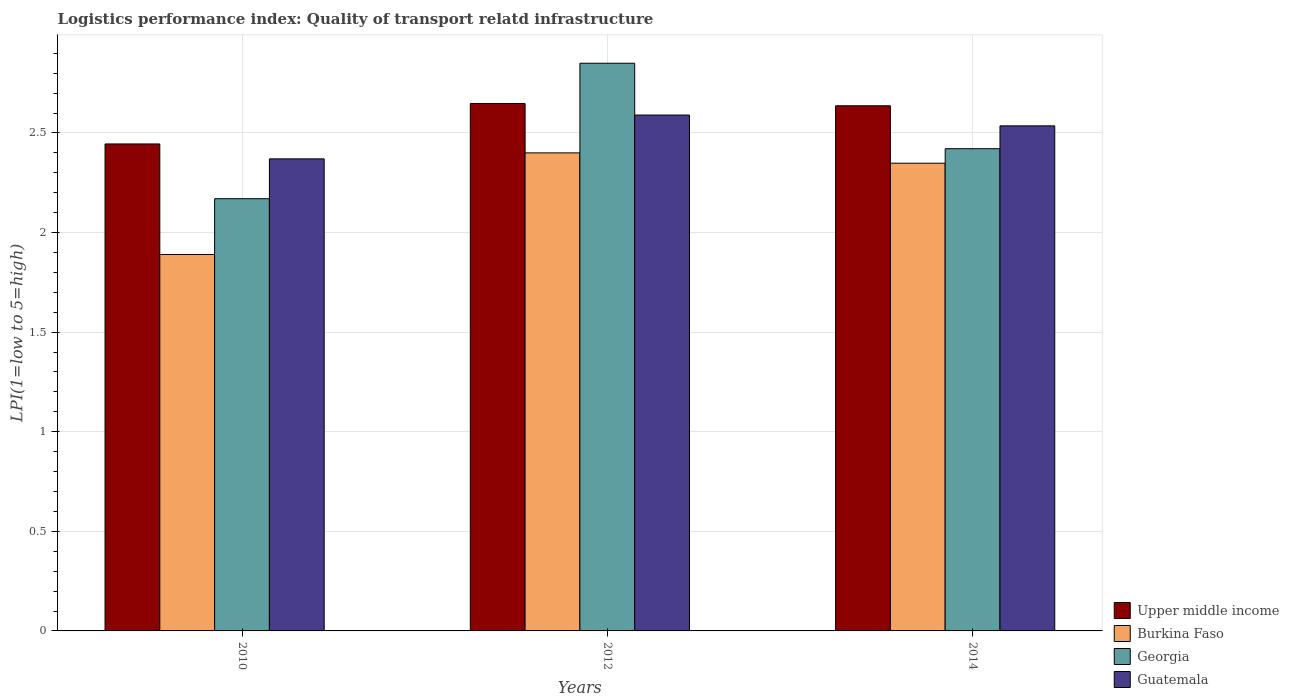Are the number of bars on each tick of the X-axis equal?
Provide a short and direct response. Yes. What is the label of the 1st group of bars from the left?
Make the answer very short. 2010. What is the logistics performance index in Guatemala in 2010?
Make the answer very short. 2.37. Across all years, what is the minimum logistics performance index in Upper middle income?
Your answer should be very brief. 2.44. In which year was the logistics performance index in Upper middle income minimum?
Your response must be concise. 2010. What is the total logistics performance index in Upper middle income in the graph?
Offer a very short reply. 7.73. What is the difference between the logistics performance index in Burkina Faso in 2012 and that in 2014?
Your response must be concise. 0.05. What is the difference between the logistics performance index in Georgia in 2010 and the logistics performance index in Upper middle income in 2012?
Offer a terse response. -0.48. What is the average logistics performance index in Upper middle income per year?
Your answer should be very brief. 2.58. In the year 2010, what is the difference between the logistics performance index in Upper middle income and logistics performance index in Georgia?
Offer a very short reply. 0.27. In how many years, is the logistics performance index in Upper middle income greater than 2.7?
Give a very brief answer. 0. What is the ratio of the logistics performance index in Georgia in 2010 to that in 2014?
Your answer should be compact. 0.9. Is the difference between the logistics performance index in Upper middle income in 2010 and 2014 greater than the difference between the logistics performance index in Georgia in 2010 and 2014?
Provide a succinct answer. Yes. What is the difference between the highest and the second highest logistics performance index in Georgia?
Provide a short and direct response. 0.43. What is the difference between the highest and the lowest logistics performance index in Burkina Faso?
Your response must be concise. 0.51. Is the sum of the logistics performance index in Guatemala in 2012 and 2014 greater than the maximum logistics performance index in Upper middle income across all years?
Your answer should be compact. Yes. Is it the case that in every year, the sum of the logistics performance index in Upper middle income and logistics performance index in Burkina Faso is greater than the sum of logistics performance index in Guatemala and logistics performance index in Georgia?
Your response must be concise. No. What does the 1st bar from the left in 2010 represents?
Ensure brevity in your answer.  Upper middle income. What does the 1st bar from the right in 2014 represents?
Keep it short and to the point. Guatemala. Are all the bars in the graph horizontal?
Keep it short and to the point. No. What is the difference between two consecutive major ticks on the Y-axis?
Your answer should be very brief. 0.5. Does the graph contain any zero values?
Give a very brief answer. No. How many legend labels are there?
Give a very brief answer. 4. What is the title of the graph?
Make the answer very short. Logistics performance index: Quality of transport relatd infrastructure. What is the label or title of the Y-axis?
Keep it short and to the point. LPI(1=low to 5=high). What is the LPI(1=low to 5=high) of Upper middle income in 2010?
Your answer should be compact. 2.44. What is the LPI(1=low to 5=high) in Burkina Faso in 2010?
Offer a very short reply. 1.89. What is the LPI(1=low to 5=high) in Georgia in 2010?
Your answer should be very brief. 2.17. What is the LPI(1=low to 5=high) of Guatemala in 2010?
Your response must be concise. 2.37. What is the LPI(1=low to 5=high) in Upper middle income in 2012?
Provide a succinct answer. 2.65. What is the LPI(1=low to 5=high) in Georgia in 2012?
Your answer should be very brief. 2.85. What is the LPI(1=low to 5=high) of Guatemala in 2012?
Offer a terse response. 2.59. What is the LPI(1=low to 5=high) of Upper middle income in 2014?
Your answer should be compact. 2.64. What is the LPI(1=low to 5=high) of Burkina Faso in 2014?
Make the answer very short. 2.35. What is the LPI(1=low to 5=high) of Georgia in 2014?
Your answer should be very brief. 2.42. What is the LPI(1=low to 5=high) in Guatemala in 2014?
Your answer should be very brief. 2.54. Across all years, what is the maximum LPI(1=low to 5=high) in Upper middle income?
Provide a short and direct response. 2.65. Across all years, what is the maximum LPI(1=low to 5=high) in Burkina Faso?
Your answer should be very brief. 2.4. Across all years, what is the maximum LPI(1=low to 5=high) of Georgia?
Provide a short and direct response. 2.85. Across all years, what is the maximum LPI(1=low to 5=high) of Guatemala?
Offer a very short reply. 2.59. Across all years, what is the minimum LPI(1=low to 5=high) in Upper middle income?
Give a very brief answer. 2.44. Across all years, what is the minimum LPI(1=low to 5=high) in Burkina Faso?
Keep it short and to the point. 1.89. Across all years, what is the minimum LPI(1=low to 5=high) of Georgia?
Your response must be concise. 2.17. Across all years, what is the minimum LPI(1=low to 5=high) in Guatemala?
Make the answer very short. 2.37. What is the total LPI(1=low to 5=high) of Upper middle income in the graph?
Provide a short and direct response. 7.73. What is the total LPI(1=low to 5=high) in Burkina Faso in the graph?
Give a very brief answer. 6.64. What is the total LPI(1=low to 5=high) of Georgia in the graph?
Your answer should be compact. 7.44. What is the total LPI(1=low to 5=high) in Guatemala in the graph?
Give a very brief answer. 7.5. What is the difference between the LPI(1=low to 5=high) of Upper middle income in 2010 and that in 2012?
Give a very brief answer. -0.2. What is the difference between the LPI(1=low to 5=high) of Burkina Faso in 2010 and that in 2012?
Your response must be concise. -0.51. What is the difference between the LPI(1=low to 5=high) in Georgia in 2010 and that in 2012?
Provide a short and direct response. -0.68. What is the difference between the LPI(1=low to 5=high) in Guatemala in 2010 and that in 2012?
Offer a very short reply. -0.22. What is the difference between the LPI(1=low to 5=high) in Upper middle income in 2010 and that in 2014?
Give a very brief answer. -0.19. What is the difference between the LPI(1=low to 5=high) of Burkina Faso in 2010 and that in 2014?
Keep it short and to the point. -0.46. What is the difference between the LPI(1=low to 5=high) of Georgia in 2010 and that in 2014?
Provide a succinct answer. -0.25. What is the difference between the LPI(1=low to 5=high) of Guatemala in 2010 and that in 2014?
Make the answer very short. -0.17. What is the difference between the LPI(1=low to 5=high) of Upper middle income in 2012 and that in 2014?
Offer a very short reply. 0.01. What is the difference between the LPI(1=low to 5=high) of Burkina Faso in 2012 and that in 2014?
Provide a succinct answer. 0.05. What is the difference between the LPI(1=low to 5=high) in Georgia in 2012 and that in 2014?
Keep it short and to the point. 0.43. What is the difference between the LPI(1=low to 5=high) in Guatemala in 2012 and that in 2014?
Your answer should be compact. 0.05. What is the difference between the LPI(1=low to 5=high) of Upper middle income in 2010 and the LPI(1=low to 5=high) of Burkina Faso in 2012?
Your answer should be very brief. 0.04. What is the difference between the LPI(1=low to 5=high) of Upper middle income in 2010 and the LPI(1=low to 5=high) of Georgia in 2012?
Provide a short and direct response. -0.41. What is the difference between the LPI(1=low to 5=high) of Upper middle income in 2010 and the LPI(1=low to 5=high) of Guatemala in 2012?
Give a very brief answer. -0.15. What is the difference between the LPI(1=low to 5=high) in Burkina Faso in 2010 and the LPI(1=low to 5=high) in Georgia in 2012?
Make the answer very short. -0.96. What is the difference between the LPI(1=low to 5=high) of Georgia in 2010 and the LPI(1=low to 5=high) of Guatemala in 2012?
Provide a succinct answer. -0.42. What is the difference between the LPI(1=low to 5=high) in Upper middle income in 2010 and the LPI(1=low to 5=high) in Burkina Faso in 2014?
Make the answer very short. 0.1. What is the difference between the LPI(1=low to 5=high) in Upper middle income in 2010 and the LPI(1=low to 5=high) in Georgia in 2014?
Give a very brief answer. 0.02. What is the difference between the LPI(1=low to 5=high) in Upper middle income in 2010 and the LPI(1=low to 5=high) in Guatemala in 2014?
Offer a very short reply. -0.09. What is the difference between the LPI(1=low to 5=high) in Burkina Faso in 2010 and the LPI(1=low to 5=high) in Georgia in 2014?
Provide a succinct answer. -0.53. What is the difference between the LPI(1=low to 5=high) in Burkina Faso in 2010 and the LPI(1=low to 5=high) in Guatemala in 2014?
Offer a terse response. -0.65. What is the difference between the LPI(1=low to 5=high) in Georgia in 2010 and the LPI(1=low to 5=high) in Guatemala in 2014?
Keep it short and to the point. -0.37. What is the difference between the LPI(1=low to 5=high) in Upper middle income in 2012 and the LPI(1=low to 5=high) in Burkina Faso in 2014?
Your answer should be compact. 0.3. What is the difference between the LPI(1=low to 5=high) in Upper middle income in 2012 and the LPI(1=low to 5=high) in Georgia in 2014?
Offer a very short reply. 0.23. What is the difference between the LPI(1=low to 5=high) in Upper middle income in 2012 and the LPI(1=low to 5=high) in Guatemala in 2014?
Your answer should be compact. 0.11. What is the difference between the LPI(1=low to 5=high) in Burkina Faso in 2012 and the LPI(1=low to 5=high) in Georgia in 2014?
Give a very brief answer. -0.02. What is the difference between the LPI(1=low to 5=high) of Burkina Faso in 2012 and the LPI(1=low to 5=high) of Guatemala in 2014?
Offer a terse response. -0.14. What is the difference between the LPI(1=low to 5=high) in Georgia in 2012 and the LPI(1=low to 5=high) in Guatemala in 2014?
Your response must be concise. 0.31. What is the average LPI(1=low to 5=high) of Upper middle income per year?
Provide a succinct answer. 2.58. What is the average LPI(1=low to 5=high) in Burkina Faso per year?
Offer a terse response. 2.21. What is the average LPI(1=low to 5=high) of Georgia per year?
Offer a terse response. 2.48. What is the average LPI(1=low to 5=high) of Guatemala per year?
Provide a succinct answer. 2.5. In the year 2010, what is the difference between the LPI(1=low to 5=high) in Upper middle income and LPI(1=low to 5=high) in Burkina Faso?
Make the answer very short. 0.55. In the year 2010, what is the difference between the LPI(1=low to 5=high) of Upper middle income and LPI(1=low to 5=high) of Georgia?
Your answer should be very brief. 0.27. In the year 2010, what is the difference between the LPI(1=low to 5=high) of Upper middle income and LPI(1=low to 5=high) of Guatemala?
Offer a terse response. 0.07. In the year 2010, what is the difference between the LPI(1=low to 5=high) of Burkina Faso and LPI(1=low to 5=high) of Georgia?
Ensure brevity in your answer.  -0.28. In the year 2010, what is the difference between the LPI(1=low to 5=high) in Burkina Faso and LPI(1=low to 5=high) in Guatemala?
Your response must be concise. -0.48. In the year 2010, what is the difference between the LPI(1=low to 5=high) of Georgia and LPI(1=low to 5=high) of Guatemala?
Ensure brevity in your answer.  -0.2. In the year 2012, what is the difference between the LPI(1=low to 5=high) in Upper middle income and LPI(1=low to 5=high) in Burkina Faso?
Your answer should be very brief. 0.25. In the year 2012, what is the difference between the LPI(1=low to 5=high) of Upper middle income and LPI(1=low to 5=high) of Georgia?
Your answer should be compact. -0.2. In the year 2012, what is the difference between the LPI(1=low to 5=high) of Upper middle income and LPI(1=low to 5=high) of Guatemala?
Ensure brevity in your answer.  0.06. In the year 2012, what is the difference between the LPI(1=low to 5=high) in Burkina Faso and LPI(1=low to 5=high) in Georgia?
Provide a short and direct response. -0.45. In the year 2012, what is the difference between the LPI(1=low to 5=high) of Burkina Faso and LPI(1=low to 5=high) of Guatemala?
Make the answer very short. -0.19. In the year 2012, what is the difference between the LPI(1=low to 5=high) in Georgia and LPI(1=low to 5=high) in Guatemala?
Your answer should be very brief. 0.26. In the year 2014, what is the difference between the LPI(1=low to 5=high) in Upper middle income and LPI(1=low to 5=high) in Burkina Faso?
Ensure brevity in your answer.  0.29. In the year 2014, what is the difference between the LPI(1=low to 5=high) in Upper middle income and LPI(1=low to 5=high) in Georgia?
Keep it short and to the point. 0.22. In the year 2014, what is the difference between the LPI(1=low to 5=high) in Upper middle income and LPI(1=low to 5=high) in Guatemala?
Provide a succinct answer. 0.1. In the year 2014, what is the difference between the LPI(1=low to 5=high) in Burkina Faso and LPI(1=low to 5=high) in Georgia?
Make the answer very short. -0.07. In the year 2014, what is the difference between the LPI(1=low to 5=high) in Burkina Faso and LPI(1=low to 5=high) in Guatemala?
Provide a short and direct response. -0.19. In the year 2014, what is the difference between the LPI(1=low to 5=high) of Georgia and LPI(1=low to 5=high) of Guatemala?
Ensure brevity in your answer.  -0.11. What is the ratio of the LPI(1=low to 5=high) of Upper middle income in 2010 to that in 2012?
Ensure brevity in your answer.  0.92. What is the ratio of the LPI(1=low to 5=high) of Burkina Faso in 2010 to that in 2012?
Offer a terse response. 0.79. What is the ratio of the LPI(1=low to 5=high) in Georgia in 2010 to that in 2012?
Your response must be concise. 0.76. What is the ratio of the LPI(1=low to 5=high) in Guatemala in 2010 to that in 2012?
Provide a succinct answer. 0.92. What is the ratio of the LPI(1=low to 5=high) in Upper middle income in 2010 to that in 2014?
Give a very brief answer. 0.93. What is the ratio of the LPI(1=low to 5=high) in Burkina Faso in 2010 to that in 2014?
Offer a terse response. 0.8. What is the ratio of the LPI(1=low to 5=high) in Georgia in 2010 to that in 2014?
Keep it short and to the point. 0.9. What is the ratio of the LPI(1=low to 5=high) in Guatemala in 2010 to that in 2014?
Provide a short and direct response. 0.93. What is the ratio of the LPI(1=low to 5=high) in Upper middle income in 2012 to that in 2014?
Provide a short and direct response. 1. What is the ratio of the LPI(1=low to 5=high) in Burkina Faso in 2012 to that in 2014?
Your response must be concise. 1.02. What is the ratio of the LPI(1=low to 5=high) of Georgia in 2012 to that in 2014?
Offer a terse response. 1.18. What is the ratio of the LPI(1=low to 5=high) of Guatemala in 2012 to that in 2014?
Ensure brevity in your answer.  1.02. What is the difference between the highest and the second highest LPI(1=low to 5=high) in Upper middle income?
Provide a succinct answer. 0.01. What is the difference between the highest and the second highest LPI(1=low to 5=high) in Burkina Faso?
Provide a succinct answer. 0.05. What is the difference between the highest and the second highest LPI(1=low to 5=high) in Georgia?
Keep it short and to the point. 0.43. What is the difference between the highest and the second highest LPI(1=low to 5=high) of Guatemala?
Your answer should be very brief. 0.05. What is the difference between the highest and the lowest LPI(1=low to 5=high) of Upper middle income?
Give a very brief answer. 0.2. What is the difference between the highest and the lowest LPI(1=low to 5=high) of Burkina Faso?
Offer a very short reply. 0.51. What is the difference between the highest and the lowest LPI(1=low to 5=high) of Georgia?
Your answer should be compact. 0.68. What is the difference between the highest and the lowest LPI(1=low to 5=high) of Guatemala?
Keep it short and to the point. 0.22. 